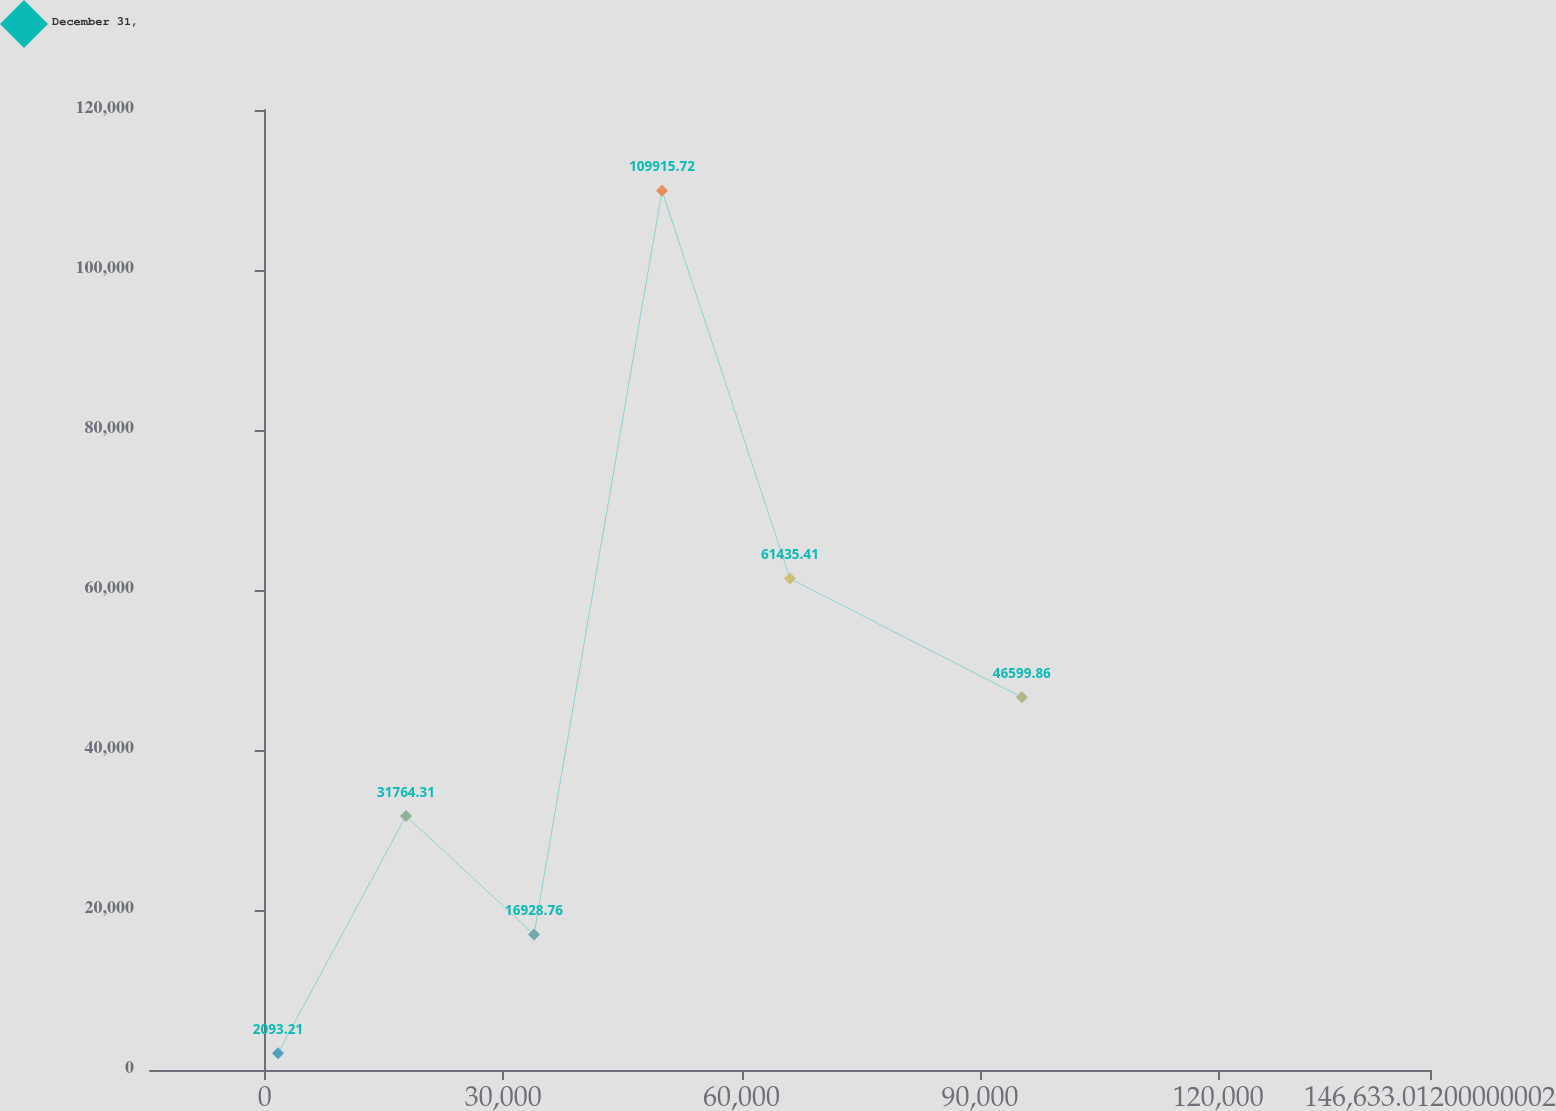<chart> <loc_0><loc_0><loc_500><loc_500><line_chart><ecel><fcel>December 31,<nl><fcel>1669.22<fcel>2093.21<nl><fcel>17776.3<fcel>31764.3<nl><fcel>33883.4<fcel>16928.8<nl><fcel>49990.5<fcel>109916<nl><fcel>66097.6<fcel>61435.4<nl><fcel>95271.9<fcel>46599.9<nl><fcel>162740<fcel>150449<nl></chart> 